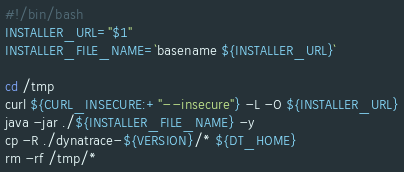<code> <loc_0><loc_0><loc_500><loc_500><_Bash_>#!/bin/bash
INSTALLER_URL="$1"
INSTALLER_FILE_NAME=`basename ${INSTALLER_URL}`

cd /tmp
curl ${CURL_INSECURE:+"--insecure"} -L -O ${INSTALLER_URL}
java -jar ./${INSTALLER_FILE_NAME} -y
cp -R ./dynatrace-${VERSION}/* ${DT_HOME}
rm -rf /tmp/*
</code> 